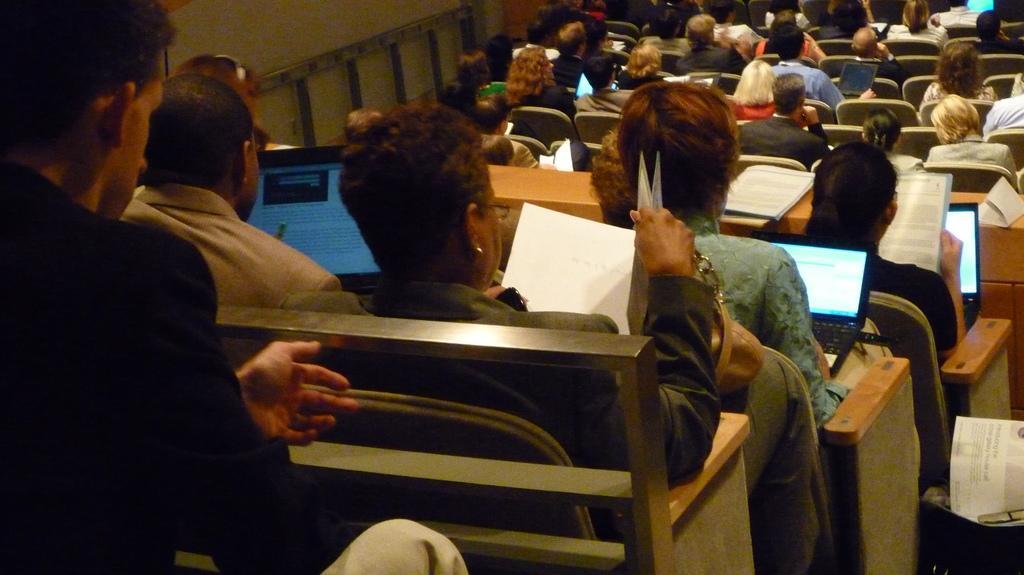Could you give a brief overview of what you see in this image? People are sitting on chairs. In-front of them there are tables, on these tables there are laptops. Few people are holding books.  